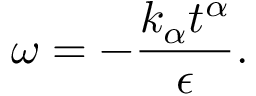Convert formula to latex. <formula><loc_0><loc_0><loc_500><loc_500>\omega = - \frac { k _ { \alpha } t ^ { \alpha } } { \epsilon } .</formula> 